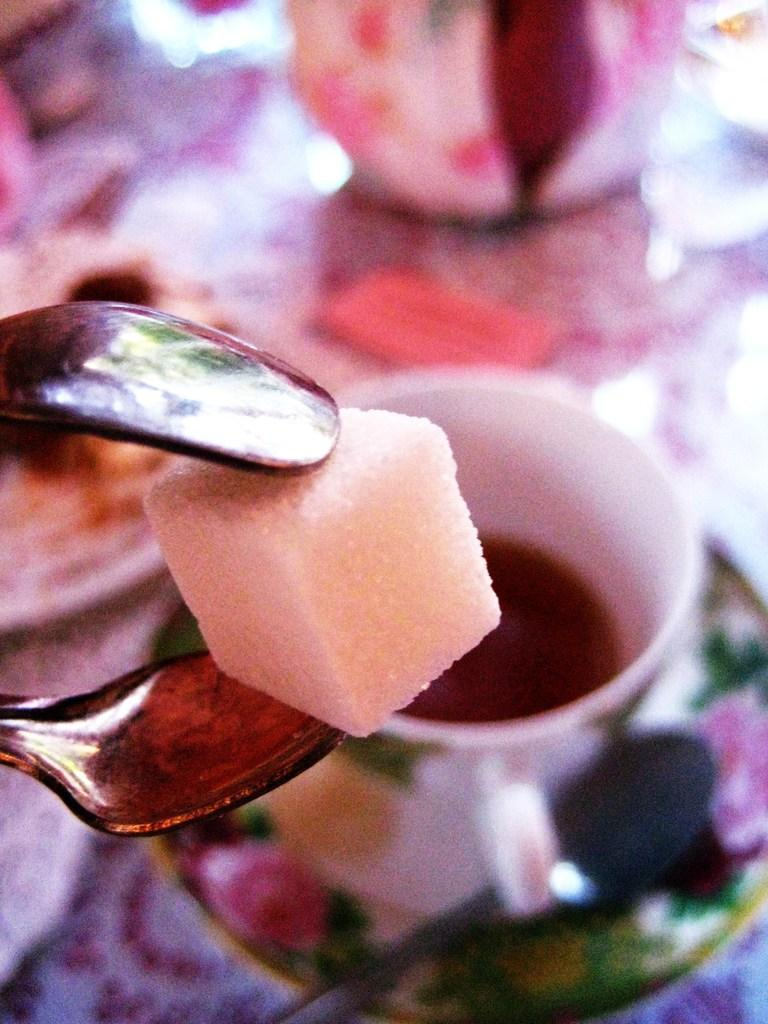What is the main object in the image? There is a holder in the image. What is the holder holding? The holder is holding a sugar cube. Can you describe the background of the image? There is a cup with a drink in the background of the image. How many units of currency can be seen in the holder? There are no units of currency present in the holder; it is holding a sugar cube. 